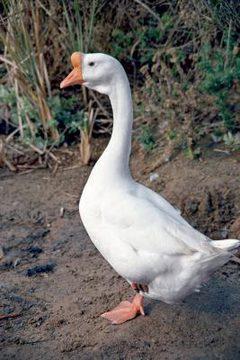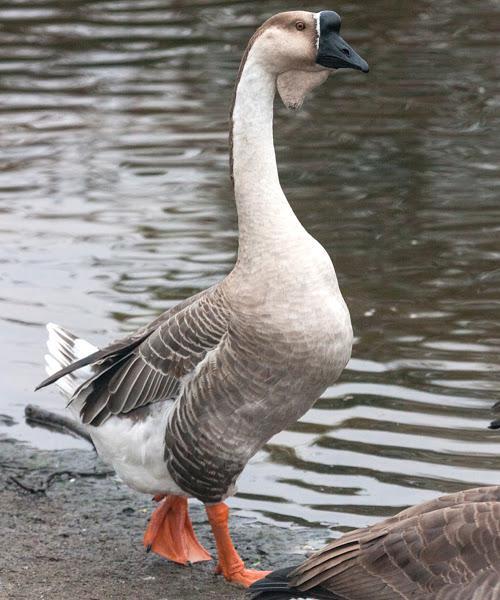The first image is the image on the left, the second image is the image on the right. Analyze the images presented: Is the assertion "An image shows one black-beaked goose standing on the water's edge." valid? Answer yes or no. Yes. The first image is the image on the left, the second image is the image on the right. Examine the images to the left and right. Is the description "There are exactly two ducks." accurate? Answer yes or no. Yes. 